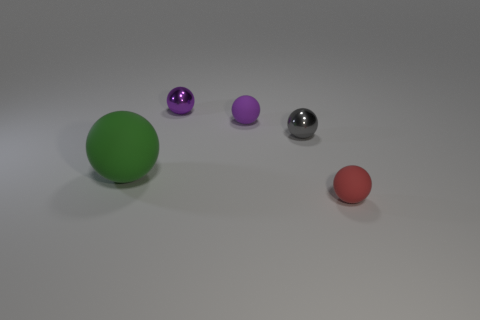Subtract all small red matte spheres. How many spheres are left? 4 Subtract all green spheres. How many spheres are left? 4 Subtract all gray balls. Subtract all gray blocks. How many balls are left? 4 Add 1 matte objects. How many objects exist? 6 Subtract 1 green balls. How many objects are left? 4 Subtract all tiny purple matte objects. Subtract all large matte things. How many objects are left? 3 Add 2 small matte objects. How many small matte objects are left? 4 Add 1 red things. How many red things exist? 2 